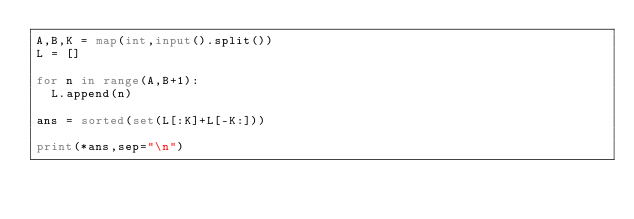Convert code to text. <code><loc_0><loc_0><loc_500><loc_500><_Python_>A,B,K = map(int,input().split())
L = []

for n in range(A,B+1):
  L.append(n)
  
ans = sorted(set(L[:K]+L[-K:]))
  
print(*ans,sep="\n")</code> 